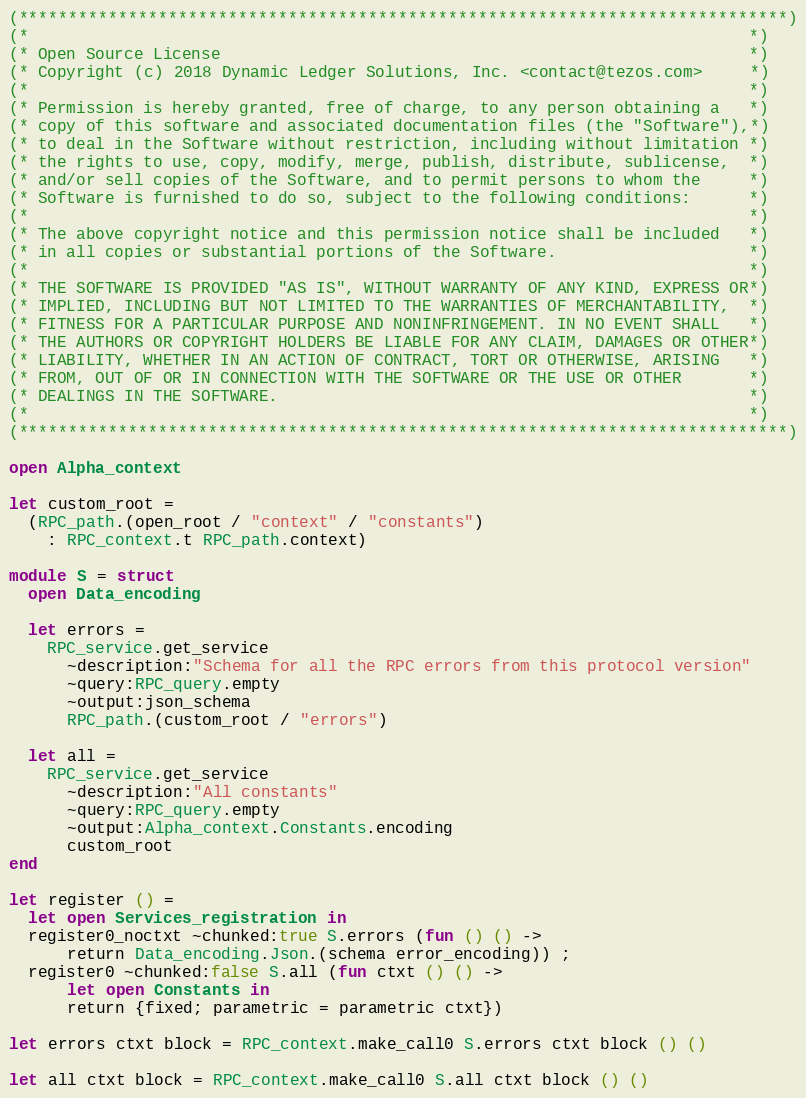Convert code to text. <code><loc_0><loc_0><loc_500><loc_500><_OCaml_>(*****************************************************************************)
(*                                                                           *)
(* Open Source License                                                       *)
(* Copyright (c) 2018 Dynamic Ledger Solutions, Inc. <contact@tezos.com>     *)
(*                                                                           *)
(* Permission is hereby granted, free of charge, to any person obtaining a   *)
(* copy of this software and associated documentation files (the "Software"),*)
(* to deal in the Software without restriction, including without limitation *)
(* the rights to use, copy, modify, merge, publish, distribute, sublicense,  *)
(* and/or sell copies of the Software, and to permit persons to whom the     *)
(* Software is furnished to do so, subject to the following conditions:      *)
(*                                                                           *)
(* The above copyright notice and this permission notice shall be included   *)
(* in all copies or substantial portions of the Software.                    *)
(*                                                                           *)
(* THE SOFTWARE IS PROVIDED "AS IS", WITHOUT WARRANTY OF ANY KIND, EXPRESS OR*)
(* IMPLIED, INCLUDING BUT NOT LIMITED TO THE WARRANTIES OF MERCHANTABILITY,  *)
(* FITNESS FOR A PARTICULAR PURPOSE AND NONINFRINGEMENT. IN NO EVENT SHALL   *)
(* THE AUTHORS OR COPYRIGHT HOLDERS BE LIABLE FOR ANY CLAIM, DAMAGES OR OTHER*)
(* LIABILITY, WHETHER IN AN ACTION OF CONTRACT, TORT OR OTHERWISE, ARISING   *)
(* FROM, OUT OF OR IN CONNECTION WITH THE SOFTWARE OR THE USE OR OTHER       *)
(* DEALINGS IN THE SOFTWARE.                                                 *)
(*                                                                           *)
(*****************************************************************************)

open Alpha_context

let custom_root =
  (RPC_path.(open_root / "context" / "constants")
    : RPC_context.t RPC_path.context)

module S = struct
  open Data_encoding

  let errors =
    RPC_service.get_service
      ~description:"Schema for all the RPC errors from this protocol version"
      ~query:RPC_query.empty
      ~output:json_schema
      RPC_path.(custom_root / "errors")

  let all =
    RPC_service.get_service
      ~description:"All constants"
      ~query:RPC_query.empty
      ~output:Alpha_context.Constants.encoding
      custom_root
end

let register () =
  let open Services_registration in
  register0_noctxt ~chunked:true S.errors (fun () () ->
      return Data_encoding.Json.(schema error_encoding)) ;
  register0 ~chunked:false S.all (fun ctxt () () ->
      let open Constants in
      return {fixed; parametric = parametric ctxt})

let errors ctxt block = RPC_context.make_call0 S.errors ctxt block () ()

let all ctxt block = RPC_context.make_call0 S.all ctxt block () ()
</code> 